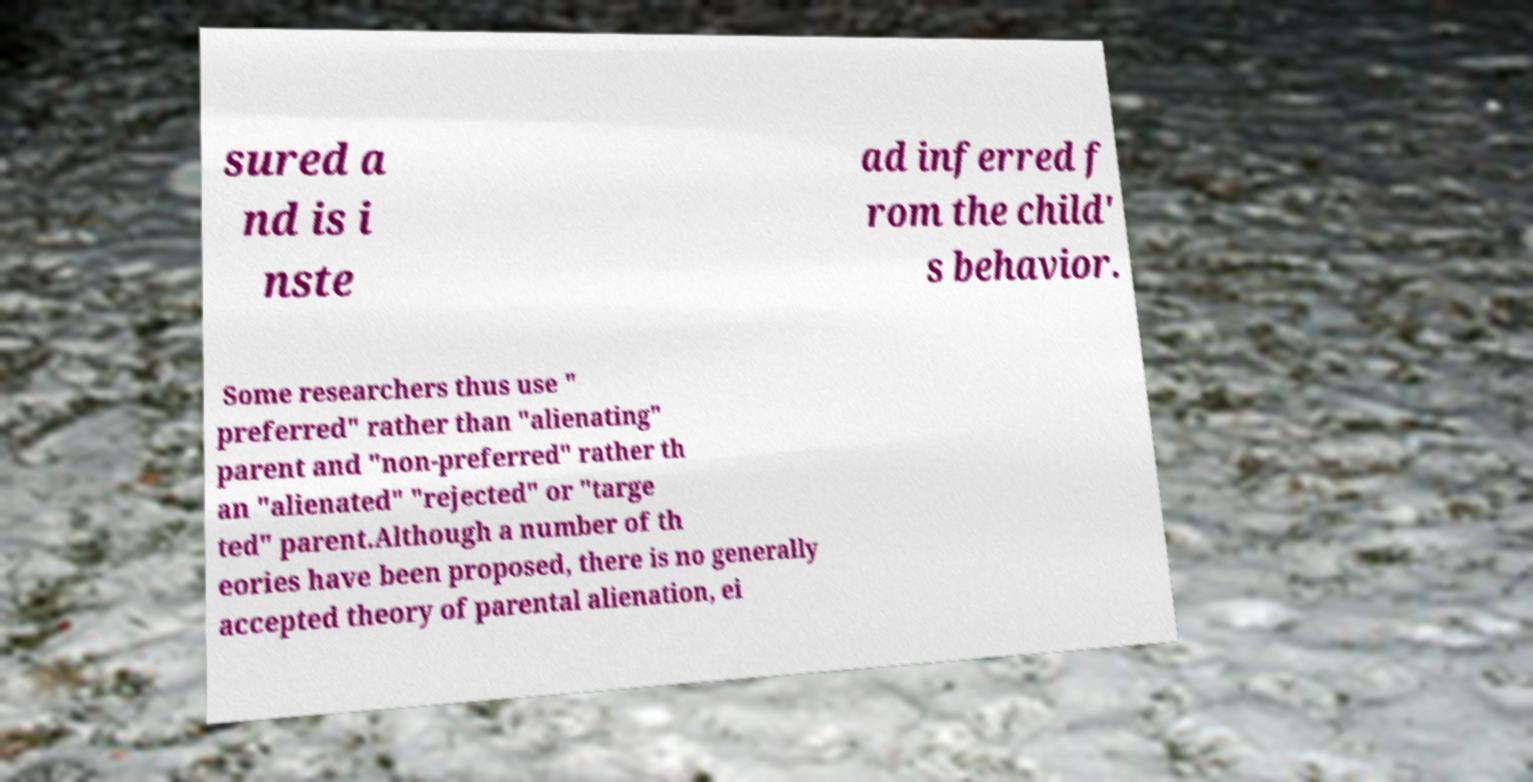Can you accurately transcribe the text from the provided image for me? sured a nd is i nste ad inferred f rom the child' s behavior. Some researchers thus use " preferred" rather than "alienating" parent and "non-preferred" rather th an "alienated" "rejected" or "targe ted" parent.Although a number of th eories have been proposed, there is no generally accepted theory of parental alienation, ei 